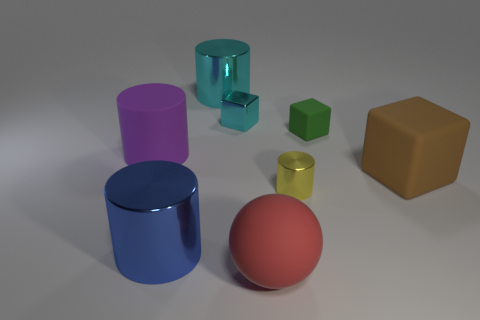What is the material of the large cylinder that is the same color as the shiny block?
Offer a very short reply. Metal. The metal thing that is the same color as the small metallic block is what size?
Make the answer very short. Large. How many spheres are either small shiny things or large blue objects?
Ensure brevity in your answer.  0. There is a large thing that is in front of the large purple cylinder and left of the cyan metal block; what is its shape?
Make the answer very short. Cylinder. Are there any cyan objects that have the same size as the green matte thing?
Your answer should be compact. Yes. What number of objects are either tiny shiny objects right of the red rubber ball or large shiny cylinders?
Your answer should be compact. 3. Does the big purple cylinder have the same material as the big cube on the right side of the green object?
Give a very brief answer. Yes. How many other objects are the same shape as the small rubber object?
Your answer should be compact. 2. How many objects are big objects to the right of the big cyan metal thing or large cylinders that are behind the green rubber object?
Provide a succinct answer. 3. What number of other things are there of the same color as the large sphere?
Keep it short and to the point. 0. 